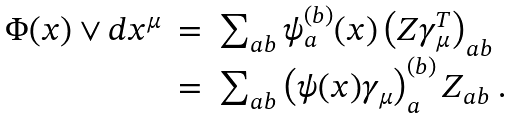<formula> <loc_0><loc_0><loc_500><loc_500>\begin{array} { c c l } \Phi ( x ) \vee d x ^ { \mu } & = & \sum _ { a b } \psi _ { a } ^ { ( b ) } ( x ) \left ( Z \gamma _ { \mu } ^ { T } \right ) _ { a b } \\ & = & \sum _ { a b } \left ( \psi ( x ) \gamma _ { \mu } \right ) _ { a } ^ { ( b ) } Z _ { a b } \ . \end{array}</formula> 